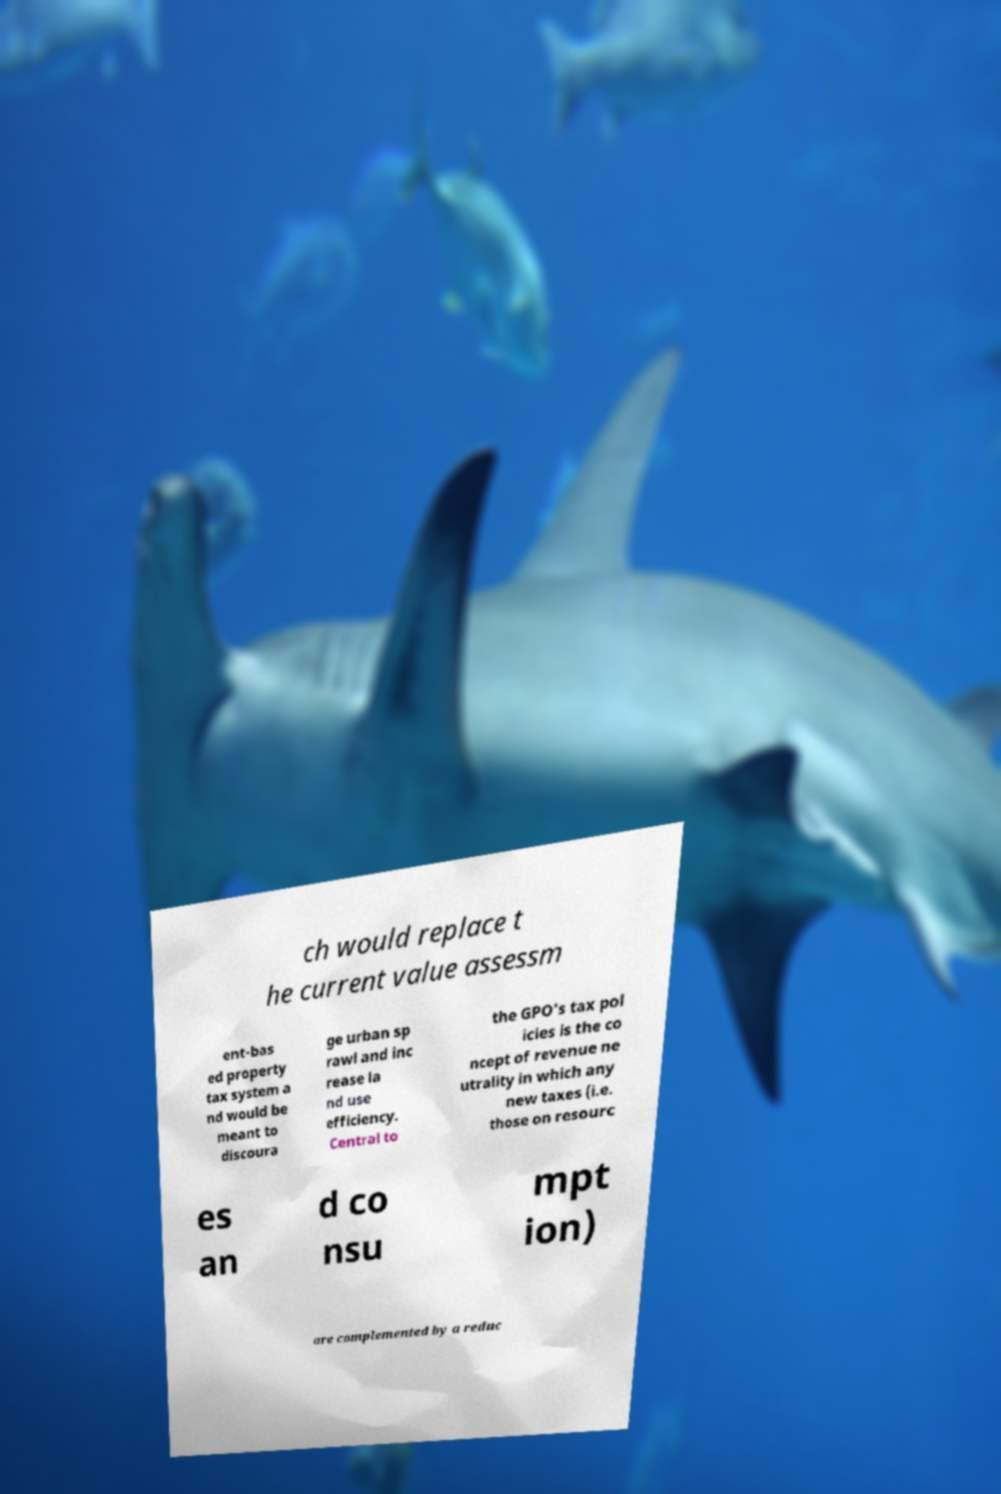I need the written content from this picture converted into text. Can you do that? ch would replace t he current value assessm ent-bas ed property tax system a nd would be meant to discoura ge urban sp rawl and inc rease la nd use efficiency. Central to the GPO's tax pol icies is the co ncept of revenue ne utrality in which any new taxes (i.e. those on resourc es an d co nsu mpt ion) are complemented by a reduc 